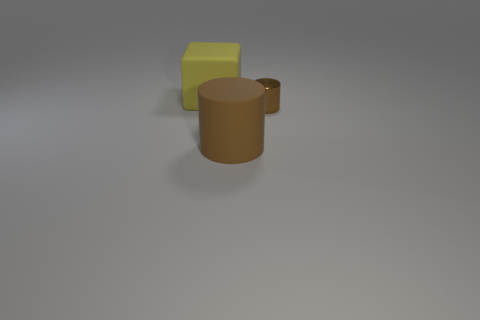Add 3 big yellow rubber objects. How many objects exist? 6 Subtract all cylinders. How many objects are left? 1 Add 1 brown matte things. How many brown matte things are left? 2 Add 1 green shiny spheres. How many green shiny spheres exist? 1 Subtract 0 purple cylinders. How many objects are left? 3 Subtract all purple metal cylinders. Subtract all tiny objects. How many objects are left? 2 